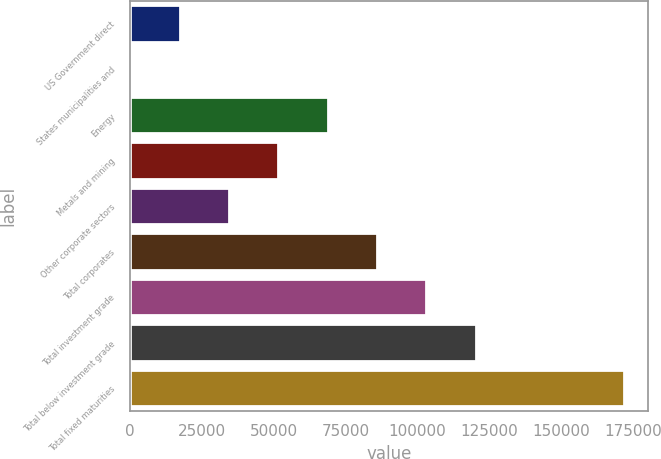Convert chart to OTSL. <chart><loc_0><loc_0><loc_500><loc_500><bar_chart><fcel>US Government direct<fcel>States municipalities and<fcel>Energy<fcel>Metals and mining<fcel>Other corporate sectors<fcel>Total corporates<fcel>Total investment grade<fcel>Total below investment grade<fcel>Total fixed maturities<nl><fcel>17211.1<fcel>42<fcel>68718.4<fcel>51549.3<fcel>34380.2<fcel>85887.5<fcel>103057<fcel>120226<fcel>171733<nl></chart> 